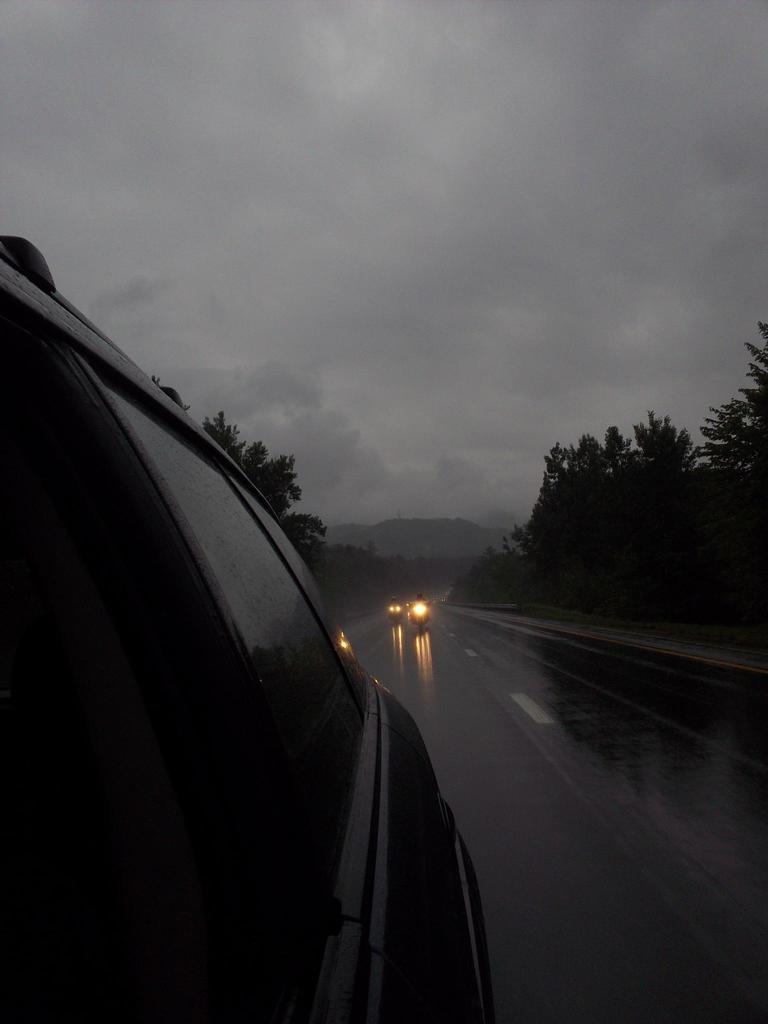Describe this image in one or two sentences. In this image there is a road, there are vehicles on the road, there are trees, there is the sky. 